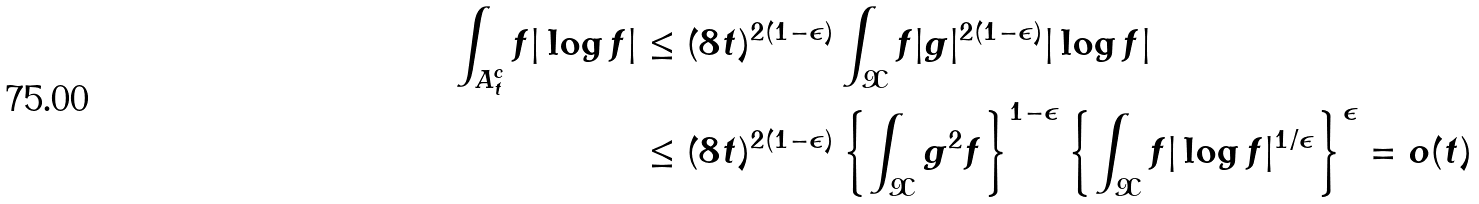<formula> <loc_0><loc_0><loc_500><loc_500>\int _ { A _ { t } ^ { c } } f | \log f | & \leq ( 8 t ) ^ { 2 ( 1 - \epsilon ) } \int _ { \mathcal { X } } f | g | ^ { 2 ( 1 - \epsilon ) } | \log f | \\ & \leq ( 8 t ) ^ { 2 ( 1 - \epsilon ) } \left \{ \int _ { \mathcal { X } } g ^ { 2 } f \right \} ^ { 1 - \epsilon } \left \{ \int _ { \mathcal { X } } f | \log f | ^ { 1 / \epsilon } \right \} ^ { \epsilon } = o ( t )</formula> 